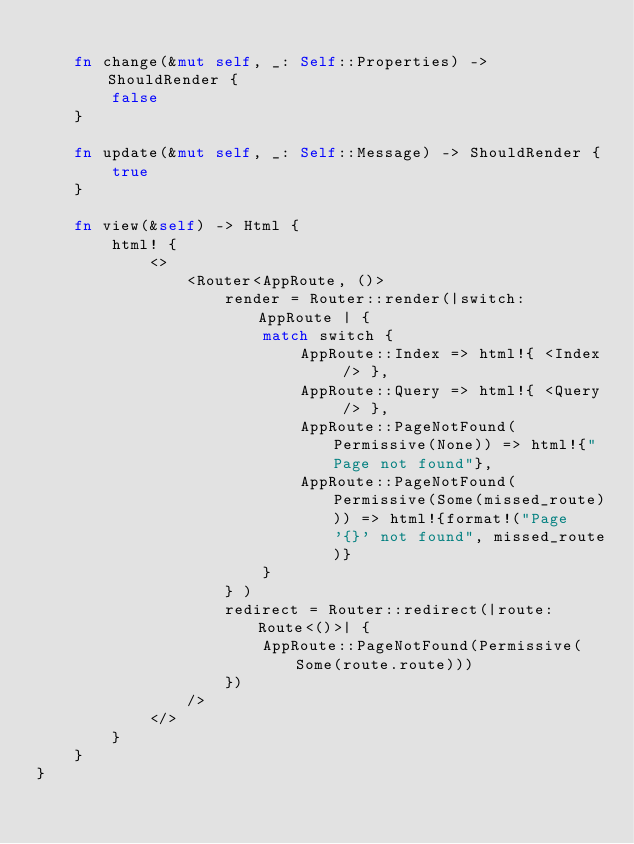<code> <loc_0><loc_0><loc_500><loc_500><_Rust_>
    fn change(&mut self, _: Self::Properties) -> ShouldRender {
        false
    }

    fn update(&mut self, _: Self::Message) -> ShouldRender {
        true
    }

    fn view(&self) -> Html {
        html! {
            <>
                <Router<AppRoute, ()>
                    render = Router::render(|switch: AppRoute | {
                        match switch {
                            AppRoute::Index => html!{ <Index /> },
                            AppRoute::Query => html!{ <Query /> },
                            AppRoute::PageNotFound(Permissive(None)) => html!{"Page not found"},
                            AppRoute::PageNotFound(Permissive(Some(missed_route))) => html!{format!("Page '{}' not found", missed_route)}
                        }
                    } )
                    redirect = Router::redirect(|route: Route<()>| {
                        AppRoute::PageNotFound(Permissive(Some(route.route)))
                    })
                />
            </>
        }
    }
}
</code> 